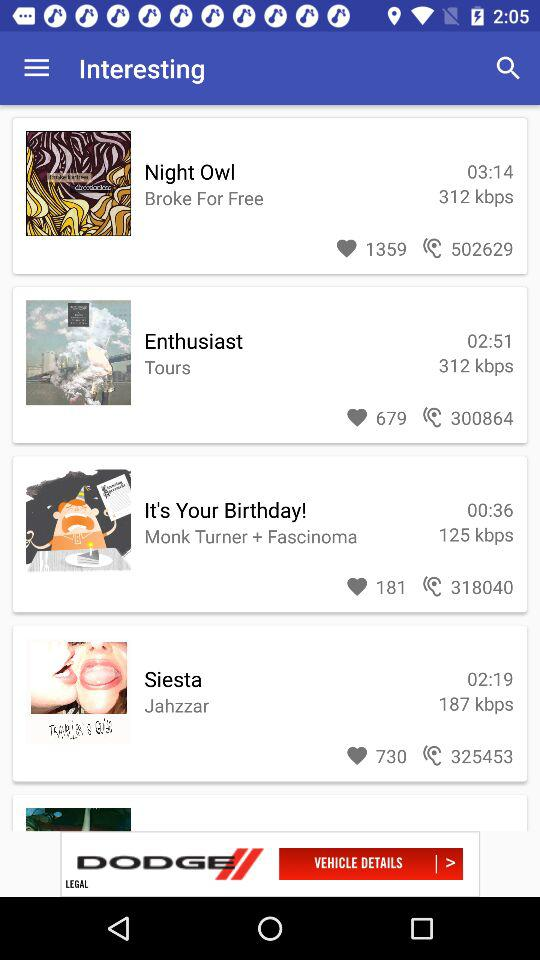What is the time duration of the enthusiast? The duration of the enthusiast is 2 minutes and 51 seconds. 